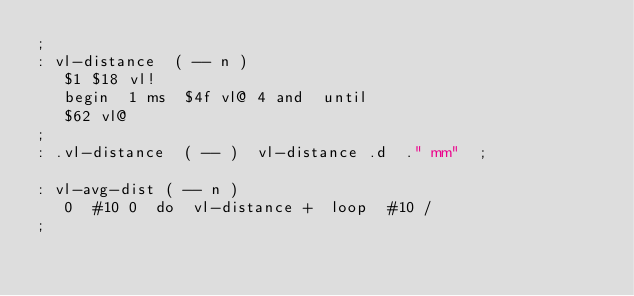<code> <loc_0><loc_0><loc_500><loc_500><_Forth_>;
: vl-distance  ( -- n )
   $1 $18 vl!
   begin  1 ms  $4f vl@ 4 and  until
   $62 vl@
;
: .vl-distance  ( -- )  vl-distance .d  ." mm"  ;

: vl-avg-dist ( -- n )
   0  #10 0  do  vl-distance +  loop  #10 /
;
</code> 